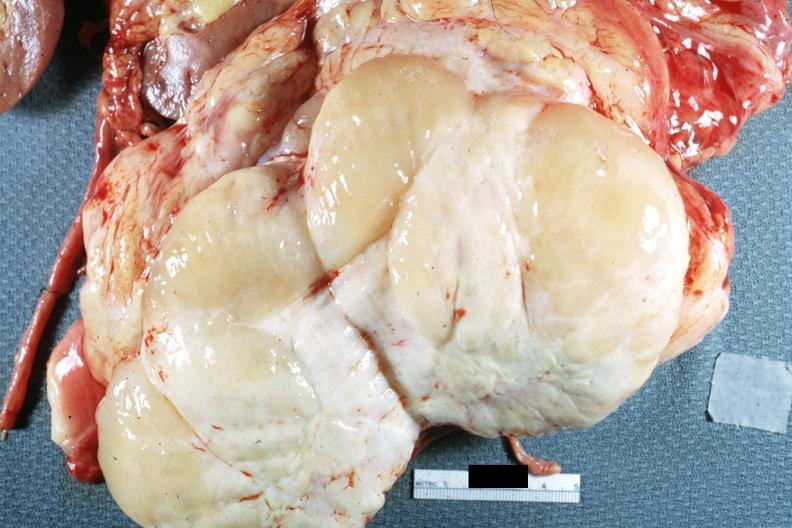how is nodular tumor cut surface natural color and white typical gross sarcoma?
Answer the question using a single word or phrase. Yellow 